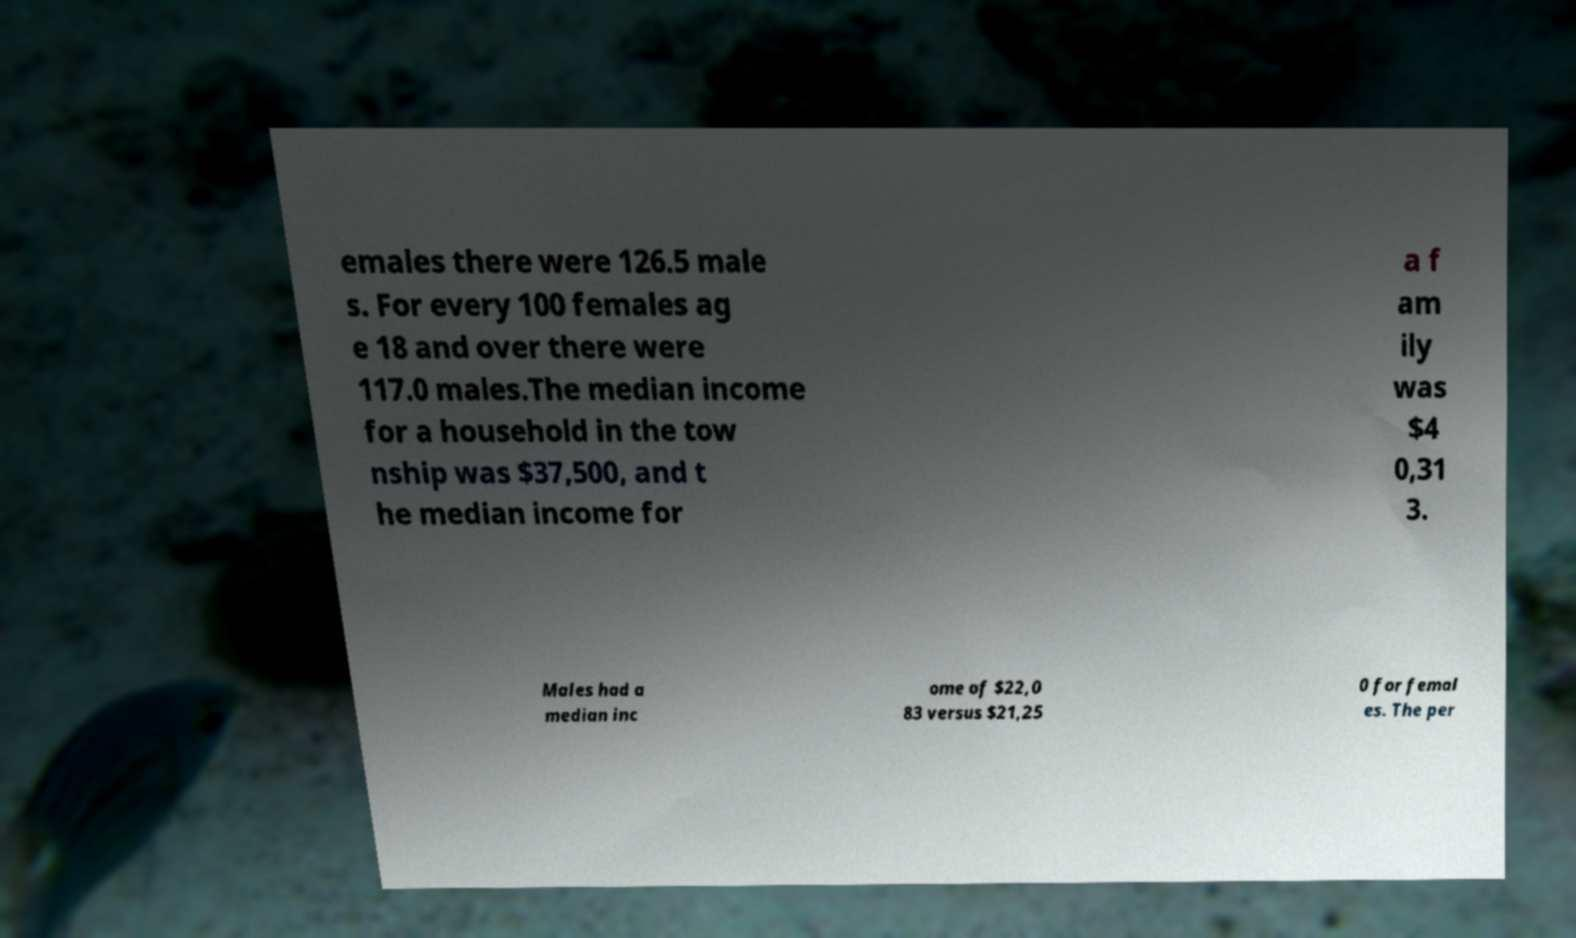Can you read and provide the text displayed in the image?This photo seems to have some interesting text. Can you extract and type it out for me? emales there were 126.5 male s. For every 100 females ag e 18 and over there were 117.0 males.The median income for a household in the tow nship was $37,500, and t he median income for a f am ily was $4 0,31 3. Males had a median inc ome of $22,0 83 versus $21,25 0 for femal es. The per 